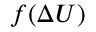Convert formula to latex. <formula><loc_0><loc_0><loc_500><loc_500>f ( \Delta U )</formula> 